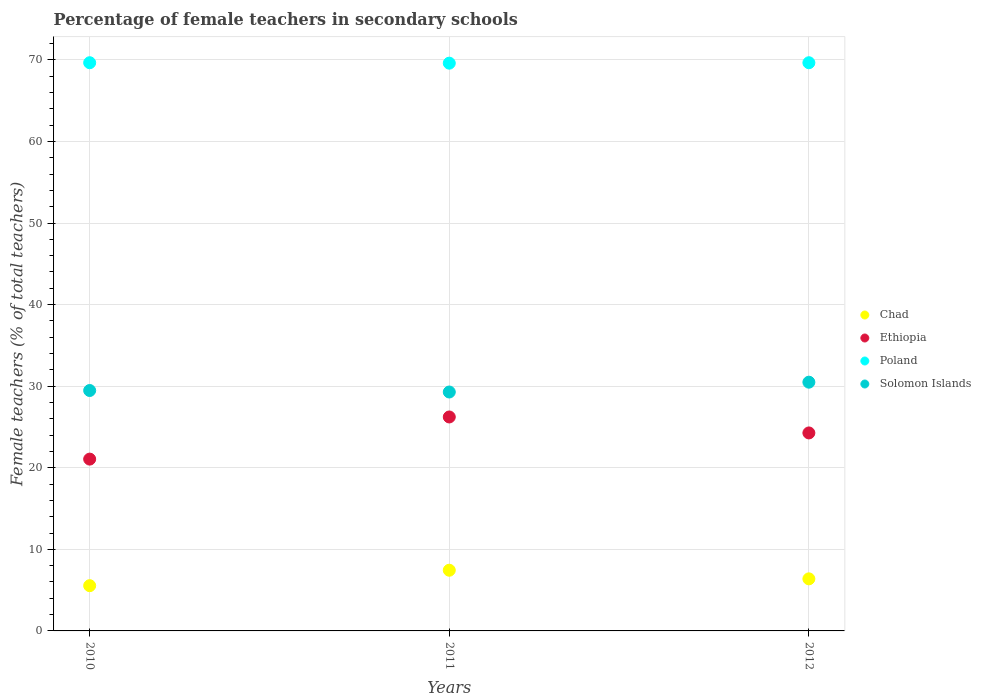What is the percentage of female teachers in Poland in 2012?
Offer a very short reply. 69.65. Across all years, what is the maximum percentage of female teachers in Chad?
Your answer should be compact. 7.44. Across all years, what is the minimum percentage of female teachers in Ethiopia?
Your answer should be compact. 21.06. In which year was the percentage of female teachers in Solomon Islands minimum?
Ensure brevity in your answer.  2011. What is the total percentage of female teachers in Solomon Islands in the graph?
Provide a short and direct response. 89.25. What is the difference between the percentage of female teachers in Poland in 2010 and that in 2012?
Your response must be concise. 0. What is the difference between the percentage of female teachers in Poland in 2011 and the percentage of female teachers in Ethiopia in 2012?
Your answer should be very brief. 45.33. What is the average percentage of female teachers in Solomon Islands per year?
Offer a terse response. 29.75. In the year 2010, what is the difference between the percentage of female teachers in Poland and percentage of female teachers in Chad?
Your answer should be compact. 64.1. In how many years, is the percentage of female teachers in Solomon Islands greater than 42 %?
Give a very brief answer. 0. What is the ratio of the percentage of female teachers in Poland in 2011 to that in 2012?
Your answer should be compact. 1. Is the percentage of female teachers in Poland in 2011 less than that in 2012?
Ensure brevity in your answer.  Yes. What is the difference between the highest and the second highest percentage of female teachers in Ethiopia?
Give a very brief answer. 1.96. What is the difference between the highest and the lowest percentage of female teachers in Poland?
Give a very brief answer. 0.05. Is it the case that in every year, the sum of the percentage of female teachers in Chad and percentage of female teachers in Solomon Islands  is greater than the sum of percentage of female teachers in Ethiopia and percentage of female teachers in Poland?
Keep it short and to the point. Yes. Does the percentage of female teachers in Ethiopia monotonically increase over the years?
Your answer should be compact. No. How many dotlines are there?
Keep it short and to the point. 4. How many years are there in the graph?
Your answer should be very brief. 3. What is the difference between two consecutive major ticks on the Y-axis?
Provide a short and direct response. 10. Does the graph contain any zero values?
Offer a terse response. No. Where does the legend appear in the graph?
Your answer should be compact. Center right. How many legend labels are there?
Provide a short and direct response. 4. What is the title of the graph?
Provide a short and direct response. Percentage of female teachers in secondary schools. What is the label or title of the X-axis?
Give a very brief answer. Years. What is the label or title of the Y-axis?
Ensure brevity in your answer.  Female teachers (% of total teachers). What is the Female teachers (% of total teachers) in Chad in 2010?
Offer a very short reply. 5.55. What is the Female teachers (% of total teachers) of Ethiopia in 2010?
Your answer should be very brief. 21.06. What is the Female teachers (% of total teachers) of Poland in 2010?
Give a very brief answer. 69.65. What is the Female teachers (% of total teachers) of Solomon Islands in 2010?
Provide a short and direct response. 29.47. What is the Female teachers (% of total teachers) of Chad in 2011?
Ensure brevity in your answer.  7.44. What is the Female teachers (% of total teachers) of Ethiopia in 2011?
Provide a succinct answer. 26.23. What is the Female teachers (% of total teachers) in Poland in 2011?
Provide a succinct answer. 69.6. What is the Female teachers (% of total teachers) of Solomon Islands in 2011?
Ensure brevity in your answer.  29.29. What is the Female teachers (% of total teachers) of Chad in 2012?
Ensure brevity in your answer.  6.38. What is the Female teachers (% of total teachers) of Ethiopia in 2012?
Provide a short and direct response. 24.27. What is the Female teachers (% of total teachers) in Poland in 2012?
Provide a succinct answer. 69.65. What is the Female teachers (% of total teachers) of Solomon Islands in 2012?
Ensure brevity in your answer.  30.49. Across all years, what is the maximum Female teachers (% of total teachers) of Chad?
Your response must be concise. 7.44. Across all years, what is the maximum Female teachers (% of total teachers) of Ethiopia?
Your answer should be compact. 26.23. Across all years, what is the maximum Female teachers (% of total teachers) in Poland?
Your response must be concise. 69.65. Across all years, what is the maximum Female teachers (% of total teachers) of Solomon Islands?
Your answer should be very brief. 30.49. Across all years, what is the minimum Female teachers (% of total teachers) of Chad?
Provide a succinct answer. 5.55. Across all years, what is the minimum Female teachers (% of total teachers) of Ethiopia?
Keep it short and to the point. 21.06. Across all years, what is the minimum Female teachers (% of total teachers) of Poland?
Keep it short and to the point. 69.6. Across all years, what is the minimum Female teachers (% of total teachers) of Solomon Islands?
Provide a succinct answer. 29.29. What is the total Female teachers (% of total teachers) of Chad in the graph?
Your response must be concise. 19.37. What is the total Female teachers (% of total teachers) of Ethiopia in the graph?
Ensure brevity in your answer.  71.56. What is the total Female teachers (% of total teachers) in Poland in the graph?
Offer a terse response. 208.9. What is the total Female teachers (% of total teachers) in Solomon Islands in the graph?
Your response must be concise. 89.25. What is the difference between the Female teachers (% of total teachers) of Chad in 2010 and that in 2011?
Make the answer very short. -1.89. What is the difference between the Female teachers (% of total teachers) in Ethiopia in 2010 and that in 2011?
Your answer should be compact. -5.17. What is the difference between the Female teachers (% of total teachers) in Poland in 2010 and that in 2011?
Your answer should be compact. 0.05. What is the difference between the Female teachers (% of total teachers) in Solomon Islands in 2010 and that in 2011?
Offer a terse response. 0.18. What is the difference between the Female teachers (% of total teachers) of Chad in 2010 and that in 2012?
Your answer should be very brief. -0.84. What is the difference between the Female teachers (% of total teachers) of Ethiopia in 2010 and that in 2012?
Give a very brief answer. -3.21. What is the difference between the Female teachers (% of total teachers) in Poland in 2010 and that in 2012?
Offer a terse response. 0. What is the difference between the Female teachers (% of total teachers) in Solomon Islands in 2010 and that in 2012?
Your answer should be very brief. -1.02. What is the difference between the Female teachers (% of total teachers) in Chad in 2011 and that in 2012?
Provide a short and direct response. 1.06. What is the difference between the Female teachers (% of total teachers) in Ethiopia in 2011 and that in 2012?
Offer a very short reply. 1.96. What is the difference between the Female teachers (% of total teachers) of Poland in 2011 and that in 2012?
Your response must be concise. -0.05. What is the difference between the Female teachers (% of total teachers) of Solomon Islands in 2011 and that in 2012?
Give a very brief answer. -1.21. What is the difference between the Female teachers (% of total teachers) of Chad in 2010 and the Female teachers (% of total teachers) of Ethiopia in 2011?
Your response must be concise. -20.68. What is the difference between the Female teachers (% of total teachers) of Chad in 2010 and the Female teachers (% of total teachers) of Poland in 2011?
Keep it short and to the point. -64.05. What is the difference between the Female teachers (% of total teachers) in Chad in 2010 and the Female teachers (% of total teachers) in Solomon Islands in 2011?
Make the answer very short. -23.74. What is the difference between the Female teachers (% of total teachers) in Ethiopia in 2010 and the Female teachers (% of total teachers) in Poland in 2011?
Ensure brevity in your answer.  -48.54. What is the difference between the Female teachers (% of total teachers) in Ethiopia in 2010 and the Female teachers (% of total teachers) in Solomon Islands in 2011?
Offer a terse response. -8.22. What is the difference between the Female teachers (% of total teachers) in Poland in 2010 and the Female teachers (% of total teachers) in Solomon Islands in 2011?
Offer a terse response. 40.36. What is the difference between the Female teachers (% of total teachers) in Chad in 2010 and the Female teachers (% of total teachers) in Ethiopia in 2012?
Offer a terse response. -18.72. What is the difference between the Female teachers (% of total teachers) in Chad in 2010 and the Female teachers (% of total teachers) in Poland in 2012?
Your response must be concise. -64.1. What is the difference between the Female teachers (% of total teachers) of Chad in 2010 and the Female teachers (% of total teachers) of Solomon Islands in 2012?
Ensure brevity in your answer.  -24.95. What is the difference between the Female teachers (% of total teachers) of Ethiopia in 2010 and the Female teachers (% of total teachers) of Poland in 2012?
Your response must be concise. -48.59. What is the difference between the Female teachers (% of total teachers) of Ethiopia in 2010 and the Female teachers (% of total teachers) of Solomon Islands in 2012?
Your answer should be very brief. -9.43. What is the difference between the Female teachers (% of total teachers) of Poland in 2010 and the Female teachers (% of total teachers) of Solomon Islands in 2012?
Offer a terse response. 39.16. What is the difference between the Female teachers (% of total teachers) of Chad in 2011 and the Female teachers (% of total teachers) of Ethiopia in 2012?
Your answer should be compact. -16.83. What is the difference between the Female teachers (% of total teachers) in Chad in 2011 and the Female teachers (% of total teachers) in Poland in 2012?
Your answer should be very brief. -62.21. What is the difference between the Female teachers (% of total teachers) in Chad in 2011 and the Female teachers (% of total teachers) in Solomon Islands in 2012?
Your response must be concise. -23.05. What is the difference between the Female teachers (% of total teachers) of Ethiopia in 2011 and the Female teachers (% of total teachers) of Poland in 2012?
Offer a terse response. -43.42. What is the difference between the Female teachers (% of total teachers) in Ethiopia in 2011 and the Female teachers (% of total teachers) in Solomon Islands in 2012?
Provide a succinct answer. -4.27. What is the difference between the Female teachers (% of total teachers) of Poland in 2011 and the Female teachers (% of total teachers) of Solomon Islands in 2012?
Ensure brevity in your answer.  39.1. What is the average Female teachers (% of total teachers) in Chad per year?
Your response must be concise. 6.46. What is the average Female teachers (% of total teachers) of Ethiopia per year?
Give a very brief answer. 23.85. What is the average Female teachers (% of total teachers) in Poland per year?
Make the answer very short. 69.63. What is the average Female teachers (% of total teachers) of Solomon Islands per year?
Give a very brief answer. 29.75. In the year 2010, what is the difference between the Female teachers (% of total teachers) of Chad and Female teachers (% of total teachers) of Ethiopia?
Give a very brief answer. -15.51. In the year 2010, what is the difference between the Female teachers (% of total teachers) in Chad and Female teachers (% of total teachers) in Poland?
Provide a short and direct response. -64.1. In the year 2010, what is the difference between the Female teachers (% of total teachers) of Chad and Female teachers (% of total teachers) of Solomon Islands?
Ensure brevity in your answer.  -23.92. In the year 2010, what is the difference between the Female teachers (% of total teachers) in Ethiopia and Female teachers (% of total teachers) in Poland?
Offer a very short reply. -48.59. In the year 2010, what is the difference between the Female teachers (% of total teachers) in Ethiopia and Female teachers (% of total teachers) in Solomon Islands?
Provide a succinct answer. -8.41. In the year 2010, what is the difference between the Female teachers (% of total teachers) in Poland and Female teachers (% of total teachers) in Solomon Islands?
Ensure brevity in your answer.  40.18. In the year 2011, what is the difference between the Female teachers (% of total teachers) of Chad and Female teachers (% of total teachers) of Ethiopia?
Keep it short and to the point. -18.79. In the year 2011, what is the difference between the Female teachers (% of total teachers) of Chad and Female teachers (% of total teachers) of Poland?
Provide a short and direct response. -62.16. In the year 2011, what is the difference between the Female teachers (% of total teachers) in Chad and Female teachers (% of total teachers) in Solomon Islands?
Offer a very short reply. -21.85. In the year 2011, what is the difference between the Female teachers (% of total teachers) of Ethiopia and Female teachers (% of total teachers) of Poland?
Provide a short and direct response. -43.37. In the year 2011, what is the difference between the Female teachers (% of total teachers) in Ethiopia and Female teachers (% of total teachers) in Solomon Islands?
Offer a terse response. -3.06. In the year 2011, what is the difference between the Female teachers (% of total teachers) in Poland and Female teachers (% of total teachers) in Solomon Islands?
Your answer should be very brief. 40.31. In the year 2012, what is the difference between the Female teachers (% of total teachers) in Chad and Female teachers (% of total teachers) in Ethiopia?
Give a very brief answer. -17.89. In the year 2012, what is the difference between the Female teachers (% of total teachers) of Chad and Female teachers (% of total teachers) of Poland?
Make the answer very short. -63.27. In the year 2012, what is the difference between the Female teachers (% of total teachers) in Chad and Female teachers (% of total teachers) in Solomon Islands?
Offer a very short reply. -24.11. In the year 2012, what is the difference between the Female teachers (% of total teachers) in Ethiopia and Female teachers (% of total teachers) in Poland?
Provide a short and direct response. -45.38. In the year 2012, what is the difference between the Female teachers (% of total teachers) of Ethiopia and Female teachers (% of total teachers) of Solomon Islands?
Offer a very short reply. -6.22. In the year 2012, what is the difference between the Female teachers (% of total teachers) in Poland and Female teachers (% of total teachers) in Solomon Islands?
Offer a terse response. 39.16. What is the ratio of the Female teachers (% of total teachers) in Chad in 2010 to that in 2011?
Provide a succinct answer. 0.75. What is the ratio of the Female teachers (% of total teachers) in Ethiopia in 2010 to that in 2011?
Your answer should be very brief. 0.8. What is the ratio of the Female teachers (% of total teachers) of Poland in 2010 to that in 2011?
Keep it short and to the point. 1. What is the ratio of the Female teachers (% of total teachers) in Solomon Islands in 2010 to that in 2011?
Provide a short and direct response. 1.01. What is the ratio of the Female teachers (% of total teachers) in Chad in 2010 to that in 2012?
Offer a very short reply. 0.87. What is the ratio of the Female teachers (% of total teachers) in Ethiopia in 2010 to that in 2012?
Ensure brevity in your answer.  0.87. What is the ratio of the Female teachers (% of total teachers) of Poland in 2010 to that in 2012?
Make the answer very short. 1. What is the ratio of the Female teachers (% of total teachers) in Solomon Islands in 2010 to that in 2012?
Your answer should be compact. 0.97. What is the ratio of the Female teachers (% of total teachers) of Chad in 2011 to that in 2012?
Provide a short and direct response. 1.17. What is the ratio of the Female teachers (% of total teachers) in Ethiopia in 2011 to that in 2012?
Give a very brief answer. 1.08. What is the ratio of the Female teachers (% of total teachers) in Solomon Islands in 2011 to that in 2012?
Keep it short and to the point. 0.96. What is the difference between the highest and the second highest Female teachers (% of total teachers) in Chad?
Make the answer very short. 1.06. What is the difference between the highest and the second highest Female teachers (% of total teachers) in Ethiopia?
Give a very brief answer. 1.96. What is the difference between the highest and the second highest Female teachers (% of total teachers) in Poland?
Keep it short and to the point. 0. What is the difference between the highest and the second highest Female teachers (% of total teachers) of Solomon Islands?
Your answer should be very brief. 1.02. What is the difference between the highest and the lowest Female teachers (% of total teachers) of Chad?
Make the answer very short. 1.89. What is the difference between the highest and the lowest Female teachers (% of total teachers) of Ethiopia?
Your answer should be very brief. 5.17. What is the difference between the highest and the lowest Female teachers (% of total teachers) of Poland?
Provide a short and direct response. 0.05. What is the difference between the highest and the lowest Female teachers (% of total teachers) of Solomon Islands?
Offer a terse response. 1.21. 